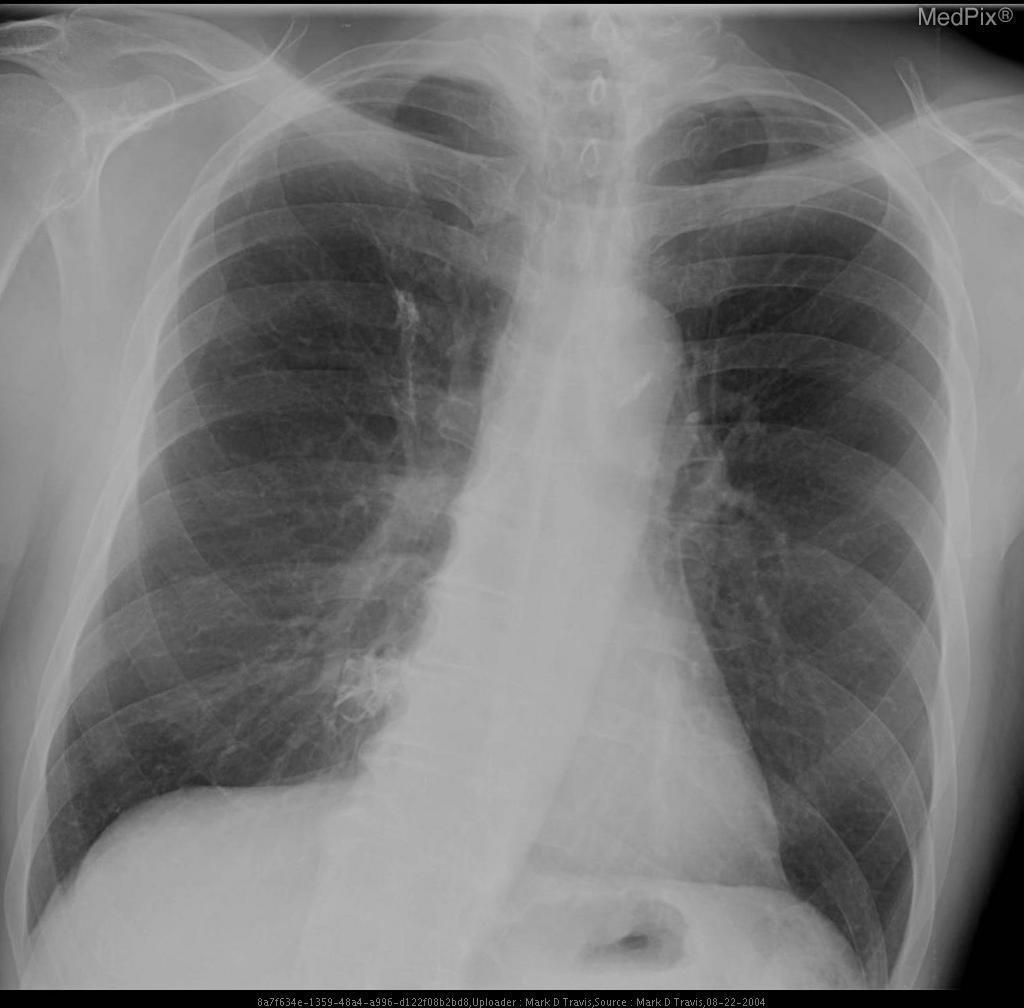Is this patient intubated?
Keep it brief. No. Is this a pa image?
Keep it brief. Yes. Does this image show a pneumothorax?
Write a very short answer. No. What type of imaging modality is seen in this image?
Short answer required. X-ray plain film. What is one organ system seen in this image?
Be succinct. Respiratory system. Does this image show a pleural effusion?
Give a very brief answer. No. 